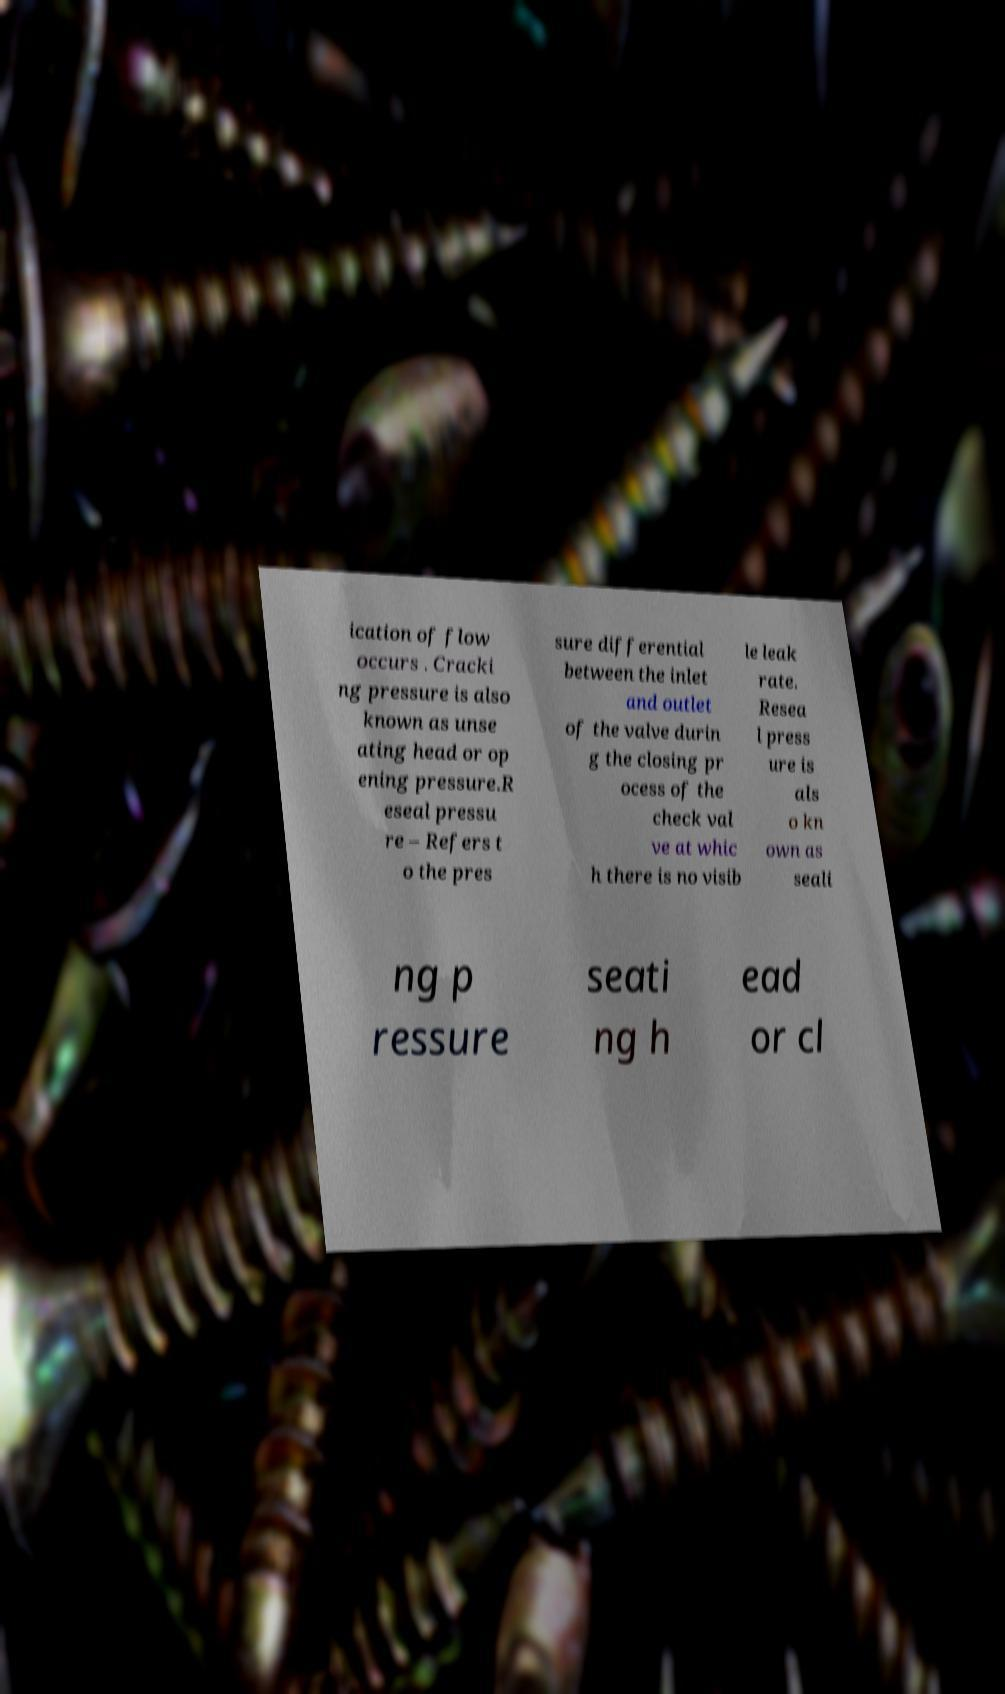For documentation purposes, I need the text within this image transcribed. Could you provide that? ication of flow occurs . Cracki ng pressure is also known as unse ating head or op ening pressure.R eseal pressu re – Refers t o the pres sure differential between the inlet and outlet of the valve durin g the closing pr ocess of the check val ve at whic h there is no visib le leak rate. Resea l press ure is als o kn own as seali ng p ressure seati ng h ead or cl 